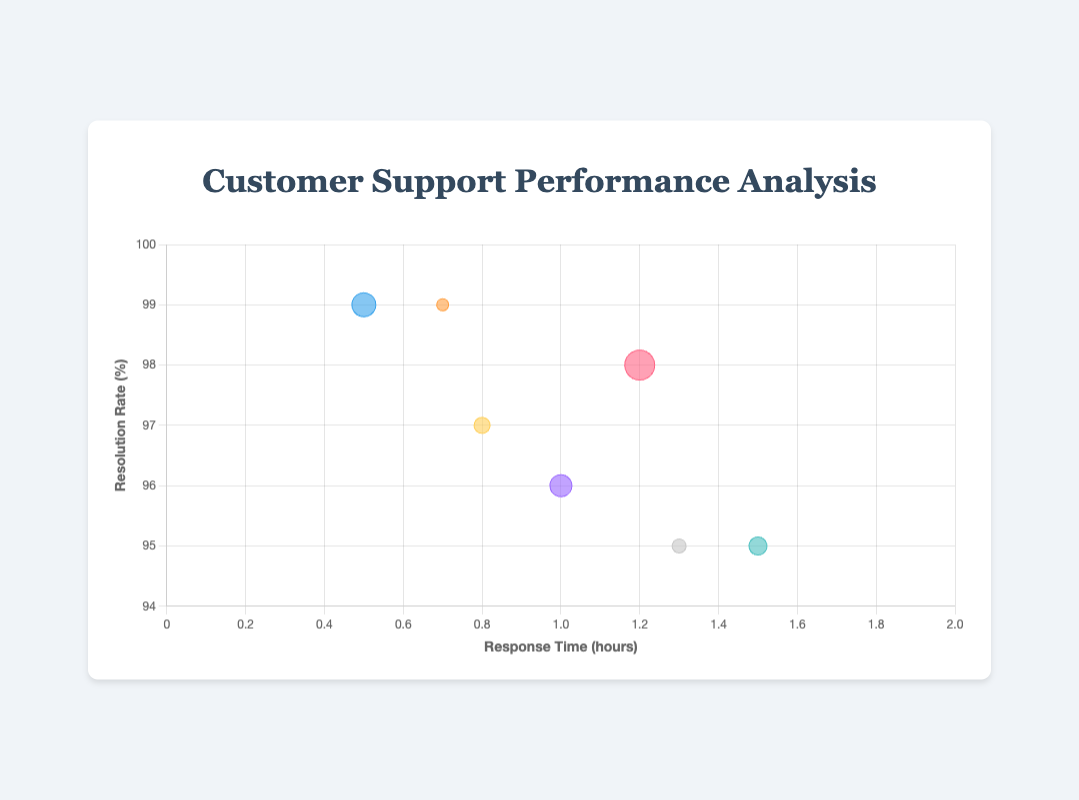What is the title of the figure? The title is usually placed at the top of the chart and is meant to give a brief description of what the chart represents. In this case, the title is centered and reads "Customer Support Performance Analysis".
Answer: Customer Support Performance Analysis Which company has the fastest average response time? By looking at the x-axis, which represents response time in hours, we find that Google has the lowest value at 0.5 hours, indicating it has the fastest response time.
Answer: Google Which company has the highest resolution rate, and what is it? The y-axis represents the resolution rate percentage. By identifying the highest bubble on the y-axis, we see that both Google and Netflix have the highest resolution rate of 99%.
Answer: Google, Netflix What is the company with the largest volume of customer support requests? The size of the bubbles represents the volume of requests. The largest bubble is associated with Amazon, indicating it has the most substantial volume of requests.
Answer: Amazon What is the difference in resolution rates between Microsoft and Facebook? Microsoft's resolution rate is 95%, and Facebook's is 96%. The difference between their resolution rates is 96% - 95% = 1%.
Answer: 1% Which company has the slowest response time and what is the value? By looking at the x-axis, the company with the highest value is Microsoft with a response time of 1.5 hours, making it the slowest.
Answer: Microsoft, 1.5 hours If the average resolution rate for all companies were calculated, what would it be? To find the average resolution rate, sum all the resolution rates and divide by the number of companies: (98 + 99 + 97 + 95 + 96 + 99 + 95) / 7 ≈ 97.
Answer: 97 How do the resolution rates of Amazon and Apple compare? Amazon has a resolution rate of 98%, while Apple has a resolution rate of 97%. Amazon’s resolution rate is 1% higher than Apple’s.
Answer: Amazon’s rate is 1% higher Which company has a balance between a high resolution rate and a low response time? By examining both axes, Google stands out with a high resolution rate of 99% and a low response time of 0.5 hours, indicating balanced performance.
Answer: Google What is the average response time for companies with a resolution rate above 97%? Companies with resolution rates above 97% are Amazon, Google, and Netflix. Their response times are 1.2, 0.5, and 0.7 hours, respectively. The average response time is (1.2 + 0.5 + 0.7) / 3 ≈ 0.8 hours.
Answer: 0.8 hours 